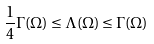Convert formula to latex. <formula><loc_0><loc_0><loc_500><loc_500>\frac { 1 } { 4 } \Gamma ( \Omega ) \leq \Lambda ( \Omega ) \leq \Gamma ( \Omega )</formula> 